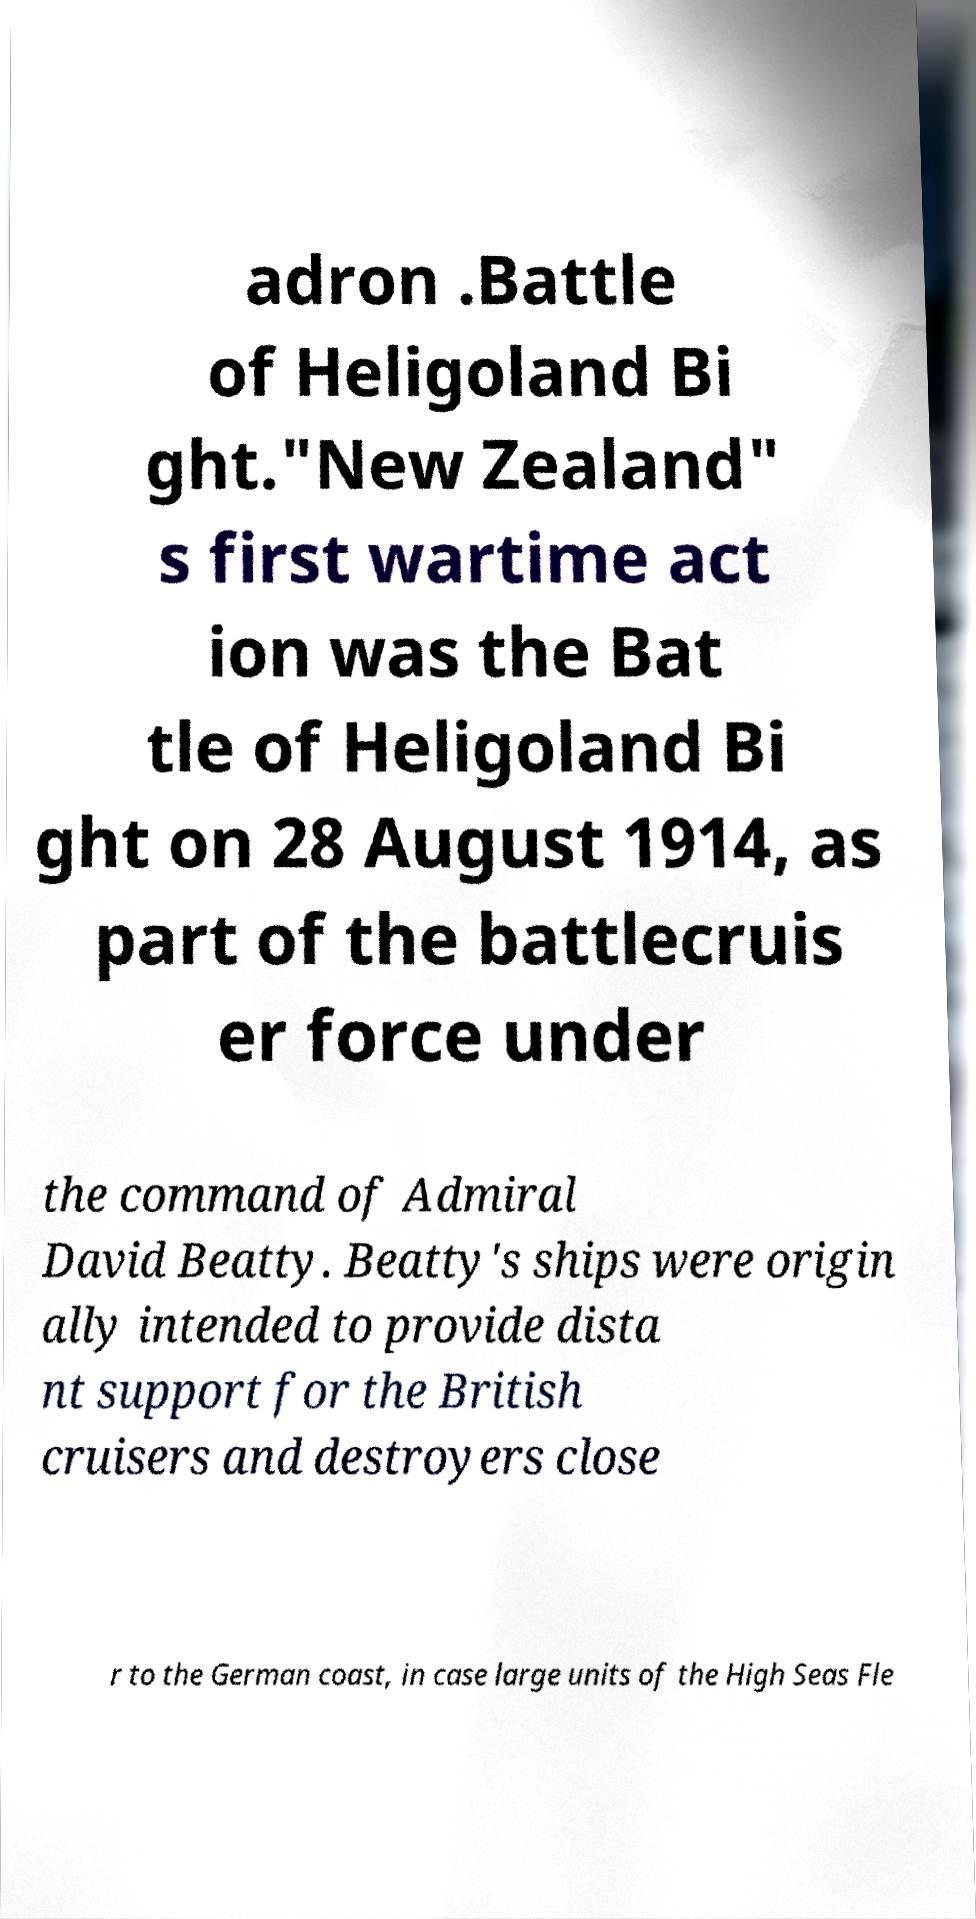For documentation purposes, I need the text within this image transcribed. Could you provide that? adron .Battle of Heligoland Bi ght."New Zealand" s first wartime act ion was the Bat tle of Heligoland Bi ght on 28 August 1914, as part of the battlecruis er force under the command of Admiral David Beatty. Beatty's ships were origin ally intended to provide dista nt support for the British cruisers and destroyers close r to the German coast, in case large units of the High Seas Fle 